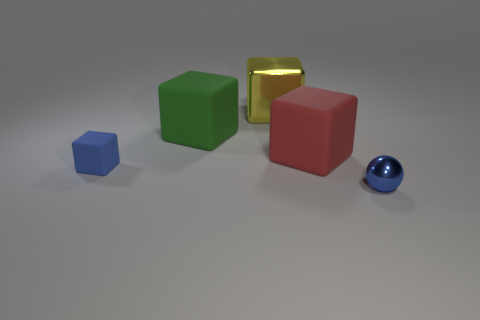Subtract 1 cubes. How many cubes are left? 3 Subtract all red cubes. How many cubes are left? 3 Add 4 small metallic objects. How many objects exist? 9 Subtract all red rubber blocks. How many blocks are left? 3 Subtract all purple blocks. Subtract all red balls. How many blocks are left? 4 Subtract all spheres. How many objects are left? 4 Subtract all blue matte cubes. Subtract all small gray metallic balls. How many objects are left? 4 Add 1 red rubber things. How many red rubber things are left? 2 Add 1 green matte blocks. How many green matte blocks exist? 2 Subtract 0 yellow spheres. How many objects are left? 5 